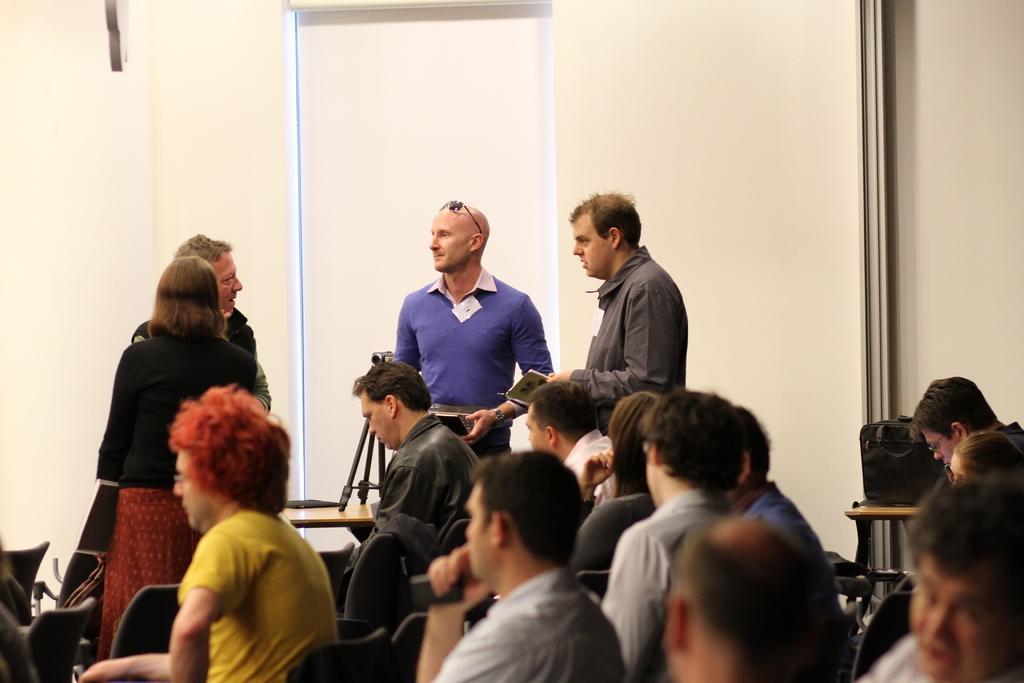In one or two sentences, can you explain what this image depicts? In front of the image there are a few people sitting on the chairs and there are a few people standing. There is a table. On top of it there is a camera stand. In the background of the image there is a window, curtain and a wall. 